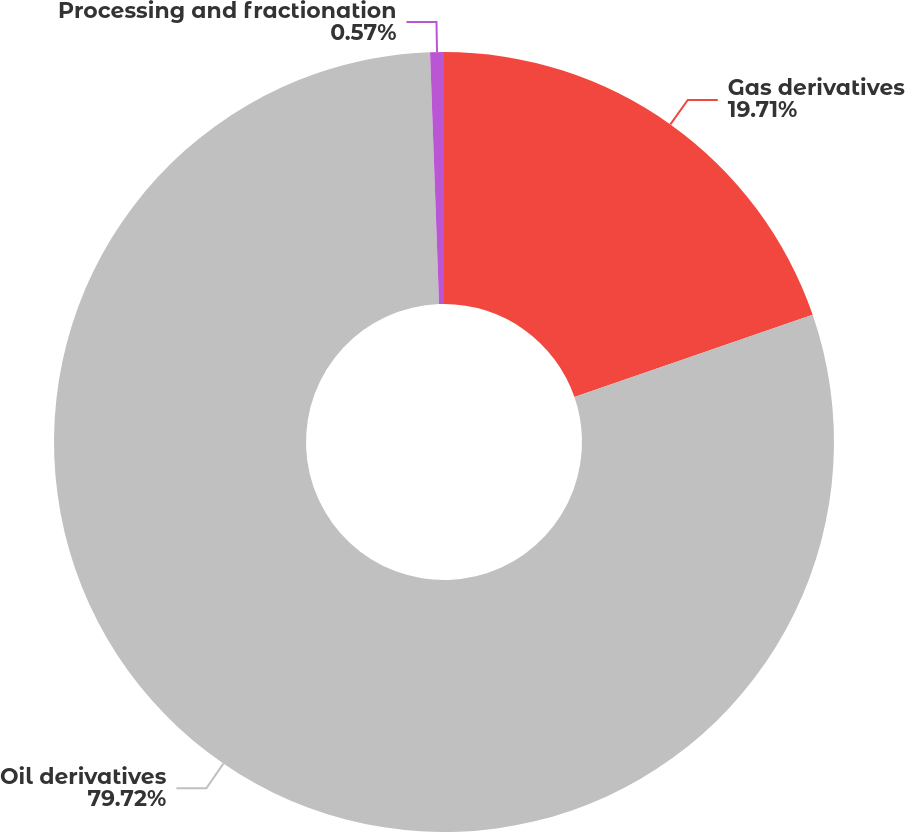Convert chart. <chart><loc_0><loc_0><loc_500><loc_500><pie_chart><fcel>Gas derivatives<fcel>Oil derivatives<fcel>Processing and fractionation<nl><fcel>19.71%<fcel>79.71%<fcel>0.57%<nl></chart> 